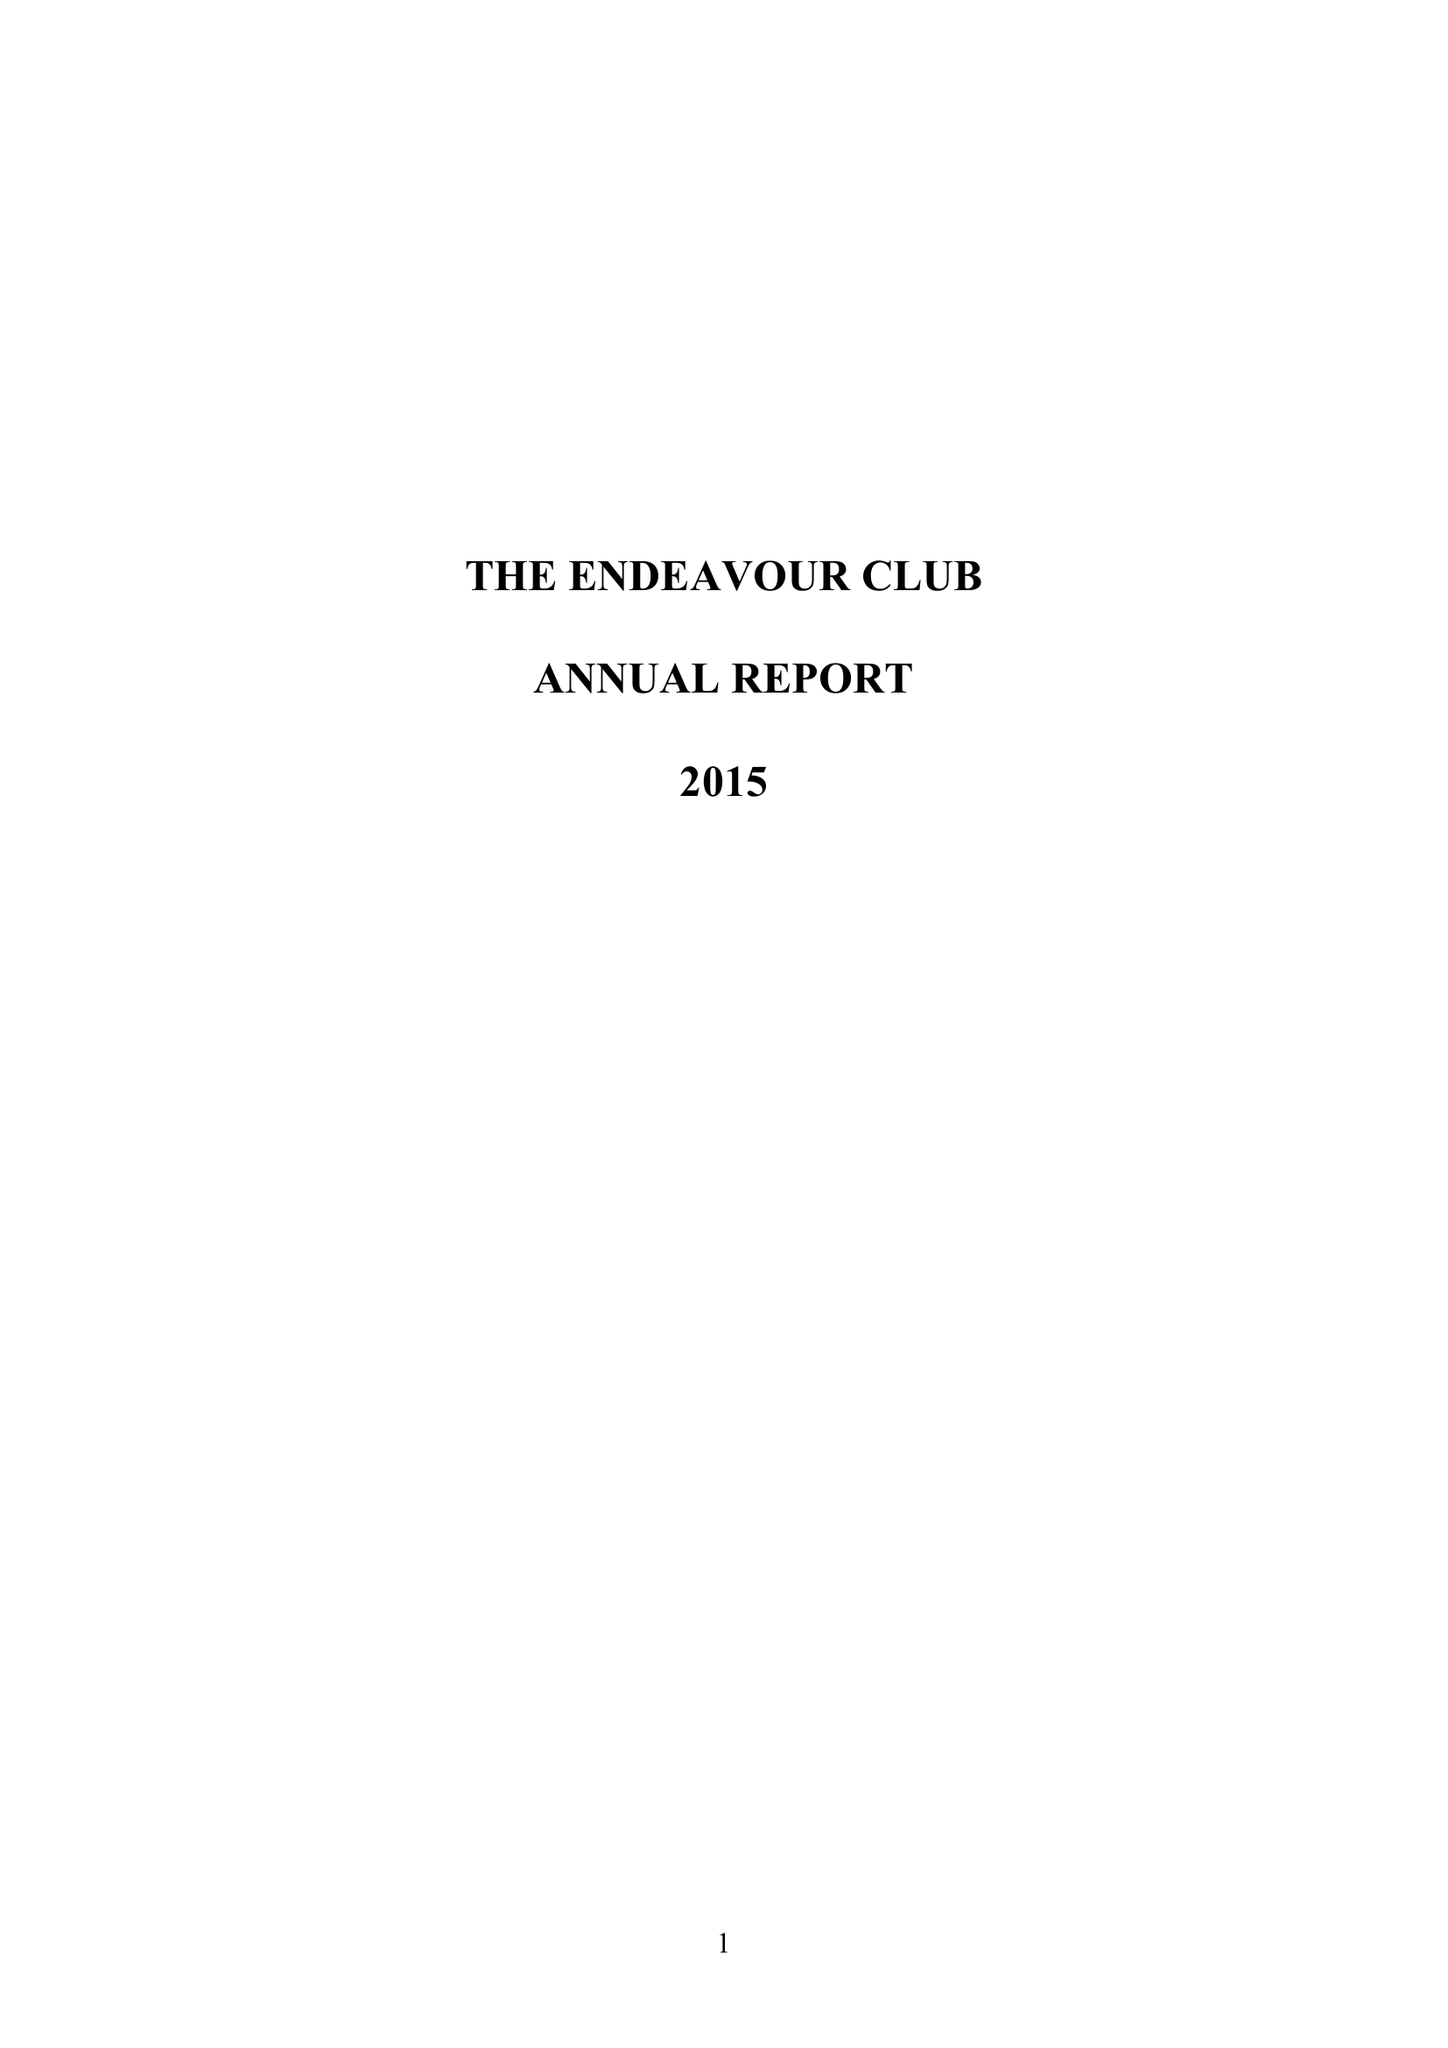What is the value for the address__postcode?
Answer the question using a single word or phrase. SM4 4AJ 